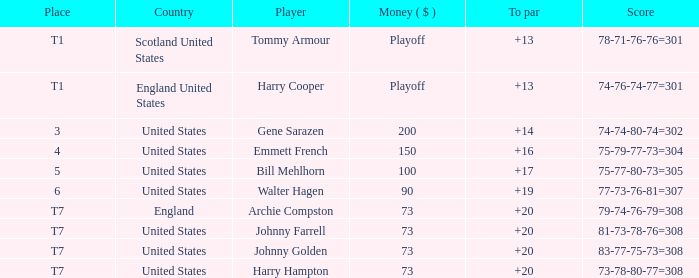What is the ranking for the United States when the money is $200? 3.0. 